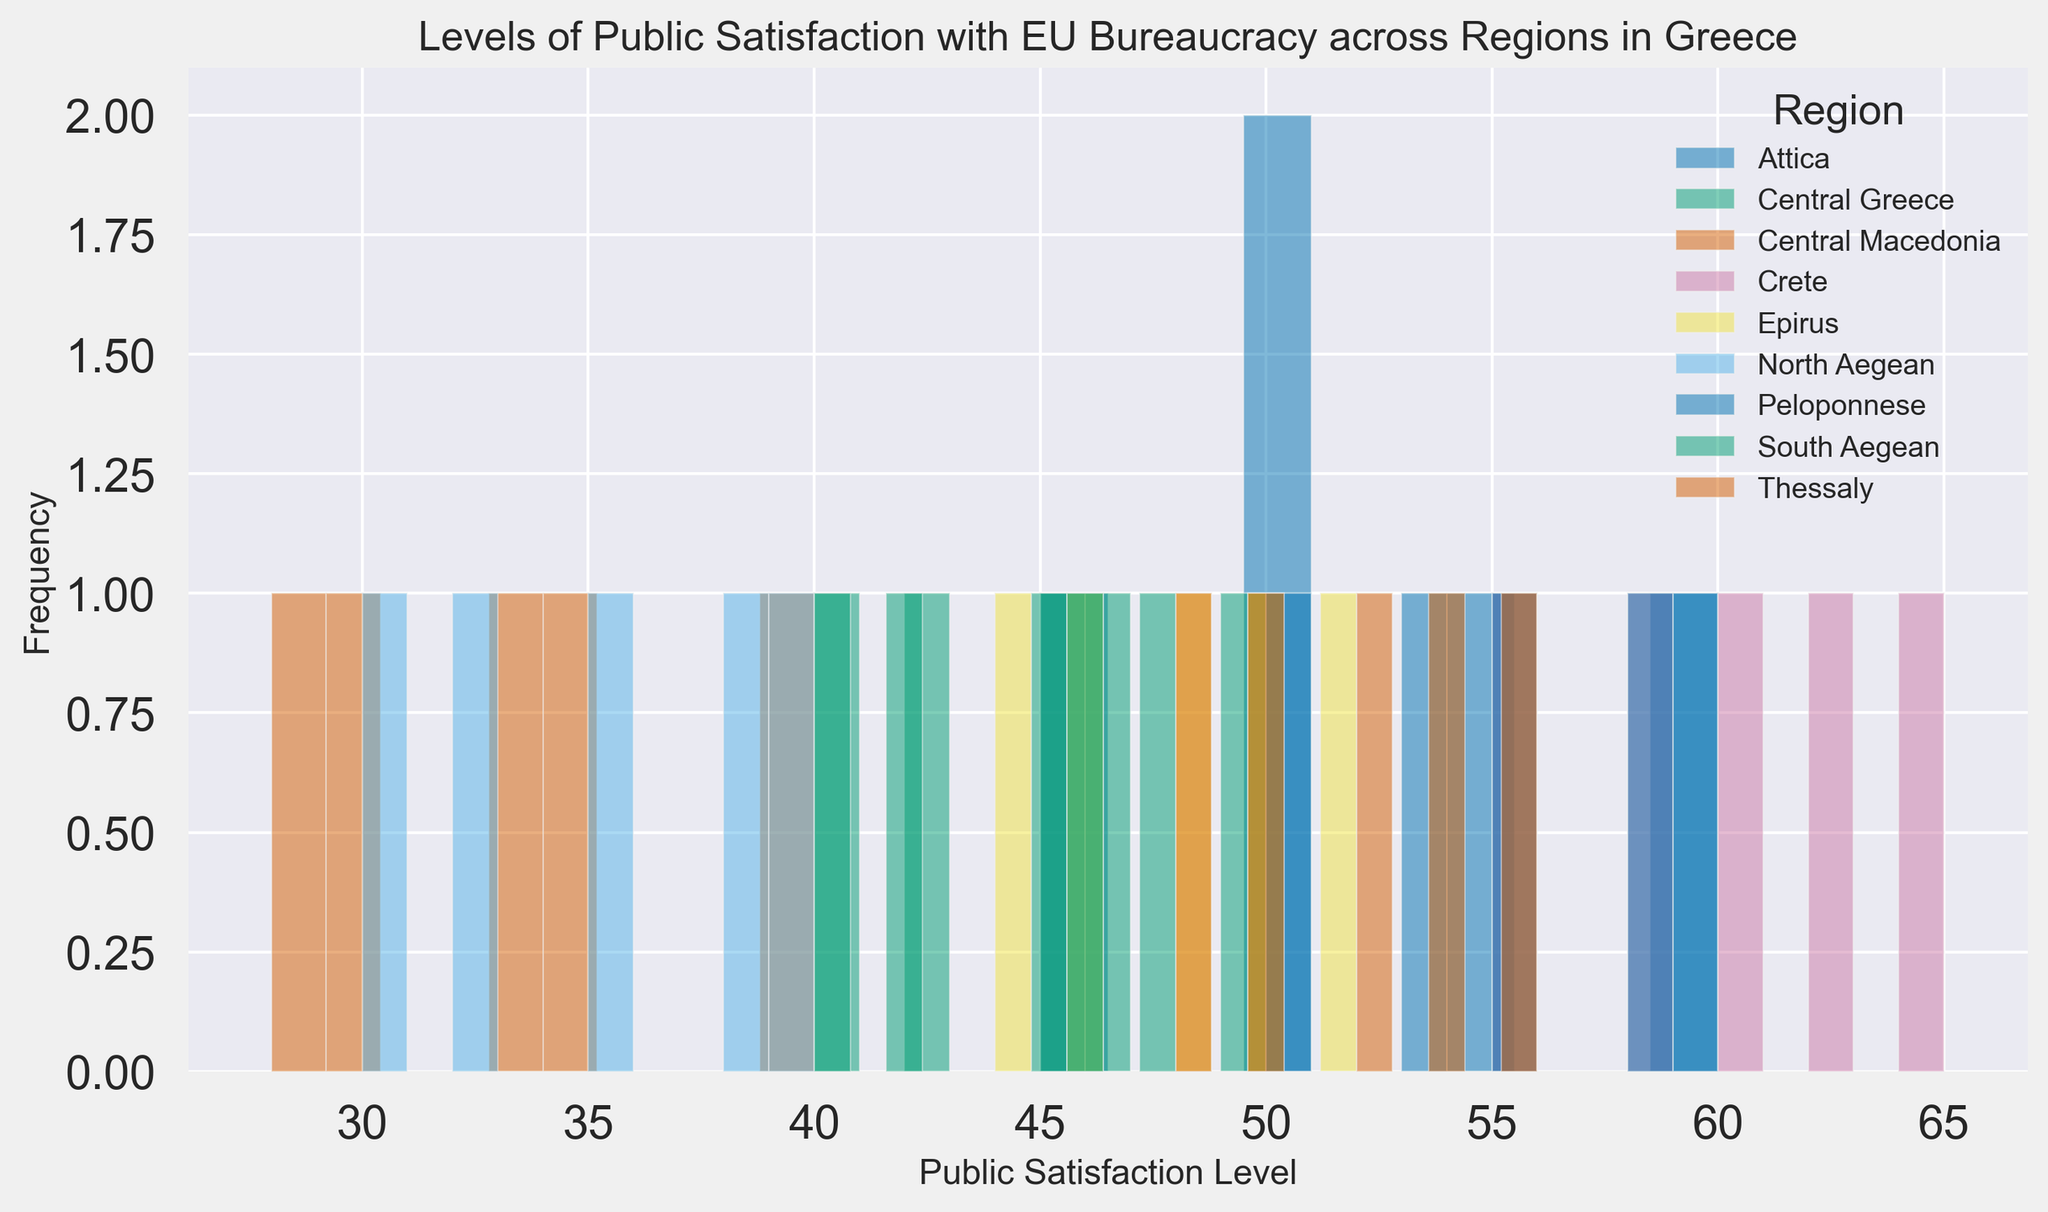Which region has the highest maximum level of public satisfaction? By looking at the end point distribution of the histogram, we identify the region with the uppermost satisfaction values. Crete's satisfaction levels peak at 65.
Answer: Crete Which region shows the widest spread of public satisfaction levels? The histogram shows that Central Macedonia's public satisfaction levels range from 28 to 40, making it the region with the widest spread.
Answer: Central Macedonia How does public satisfaction in Attica compare to Crete in terms of distribution shape? Attica shows a more uniform distribution within the bins, indicating consistent satisfaction levels, whereas Crete shows more variation with higher peaks in specific bins.
Answer: Attica is more uniform; Crete has peaks What is the range of public satisfaction levels in the South Aegean? By observing the histogram, we find that public satisfaction levels in South Aegean range from 40 to 48.
Answer: 40 to 48 How does the most frequent public satisfaction level in Central Greece compare to that in Thessaly? The histogram indicates the most frequent satisfaction level in Central Greece is around 45, while in Thessaly, it is around 50.
Answer: 45 in Central Greece, 50 in Thessaly Which region's public satisfaction histogram bars are skewed the most to the left? The histogram for Central Macedonia is highly skewed to the left, showing lower satisfaction levels concentrated on the left side.
Answer: Central Macedonia What's the average of the highest levels of public satisfaction across all regions? By identifying the maximum levels of the histogram bars for each region (Attica: 60, Central Greece: 46, Central Macedonia: 40, Crete: 65, Epirus: 52, North Aegean: 40, Peloponnese: 60, South Aegean: 48, Thessaly: 56), summing them up (60+46+40+65+52+40+60+48+56) gives 467. Dividing by the number of regions (9) results in approximately 51.89.
Answer: 51.89 